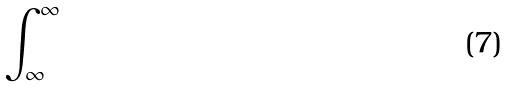Convert formula to latex. <formula><loc_0><loc_0><loc_500><loc_500>\int _ { \infty } ^ { \infty }</formula> 